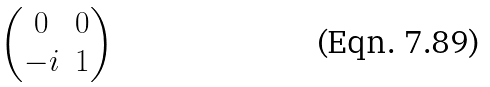Convert formula to latex. <formula><loc_0><loc_0><loc_500><loc_500>\begin{pmatrix} 0 & 0 \\ - i & 1 \end{pmatrix}</formula> 